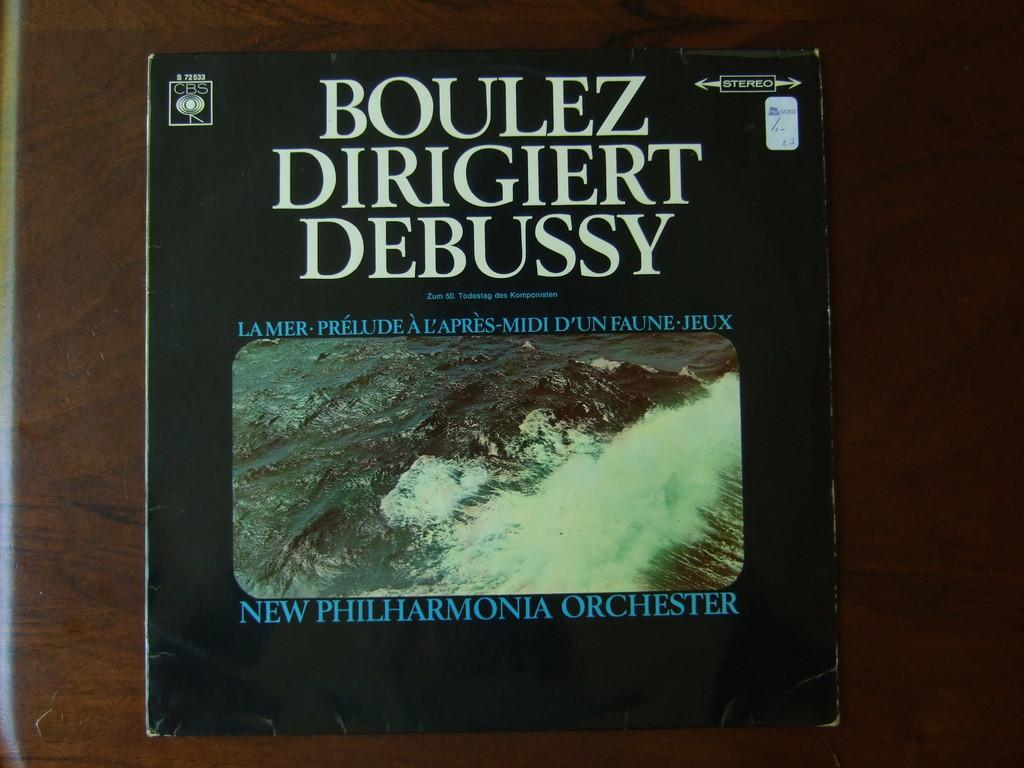<image>
Render a clear and concise summary of the photo. a vinyl cover of Boulez Dirigiert Debussy by the new philharmonia orchester. 